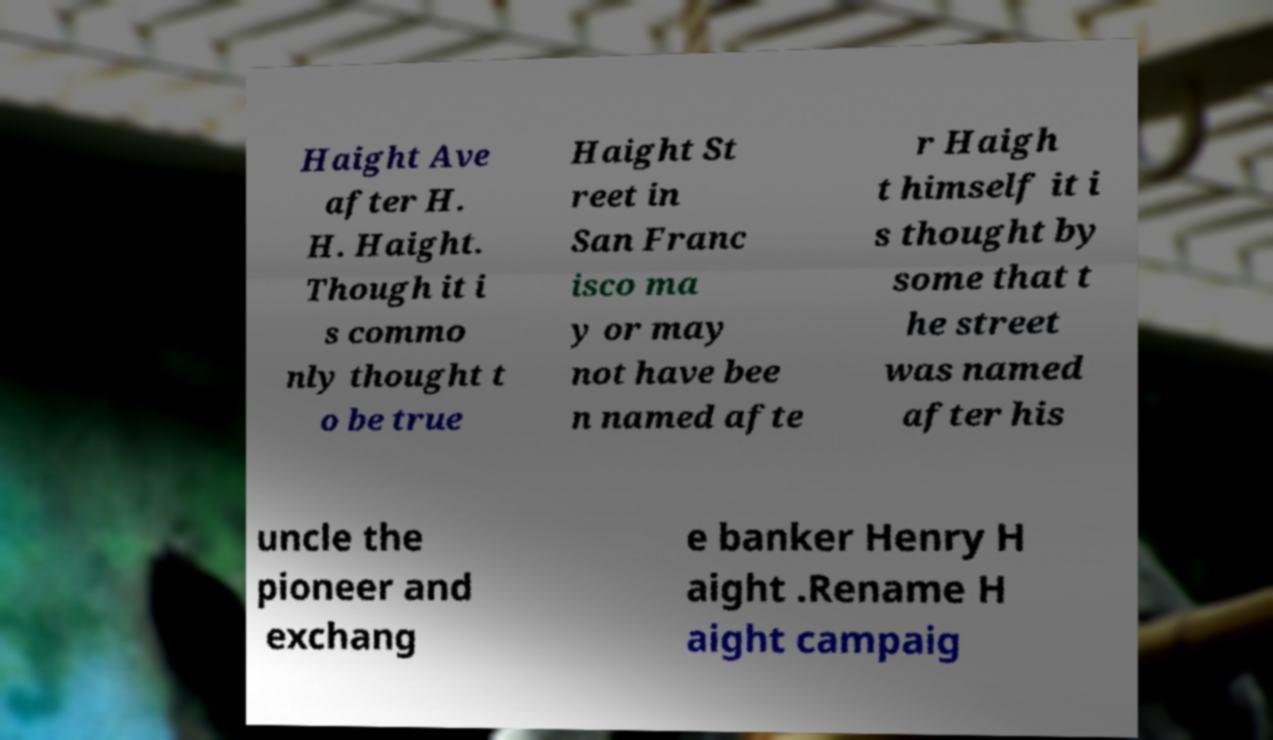Can you accurately transcribe the text from the provided image for me? Haight Ave after H. H. Haight. Though it i s commo nly thought t o be true Haight St reet in San Franc isco ma y or may not have bee n named afte r Haigh t himself it i s thought by some that t he street was named after his uncle the pioneer and exchang e banker Henry H aight .Rename H aight campaig 